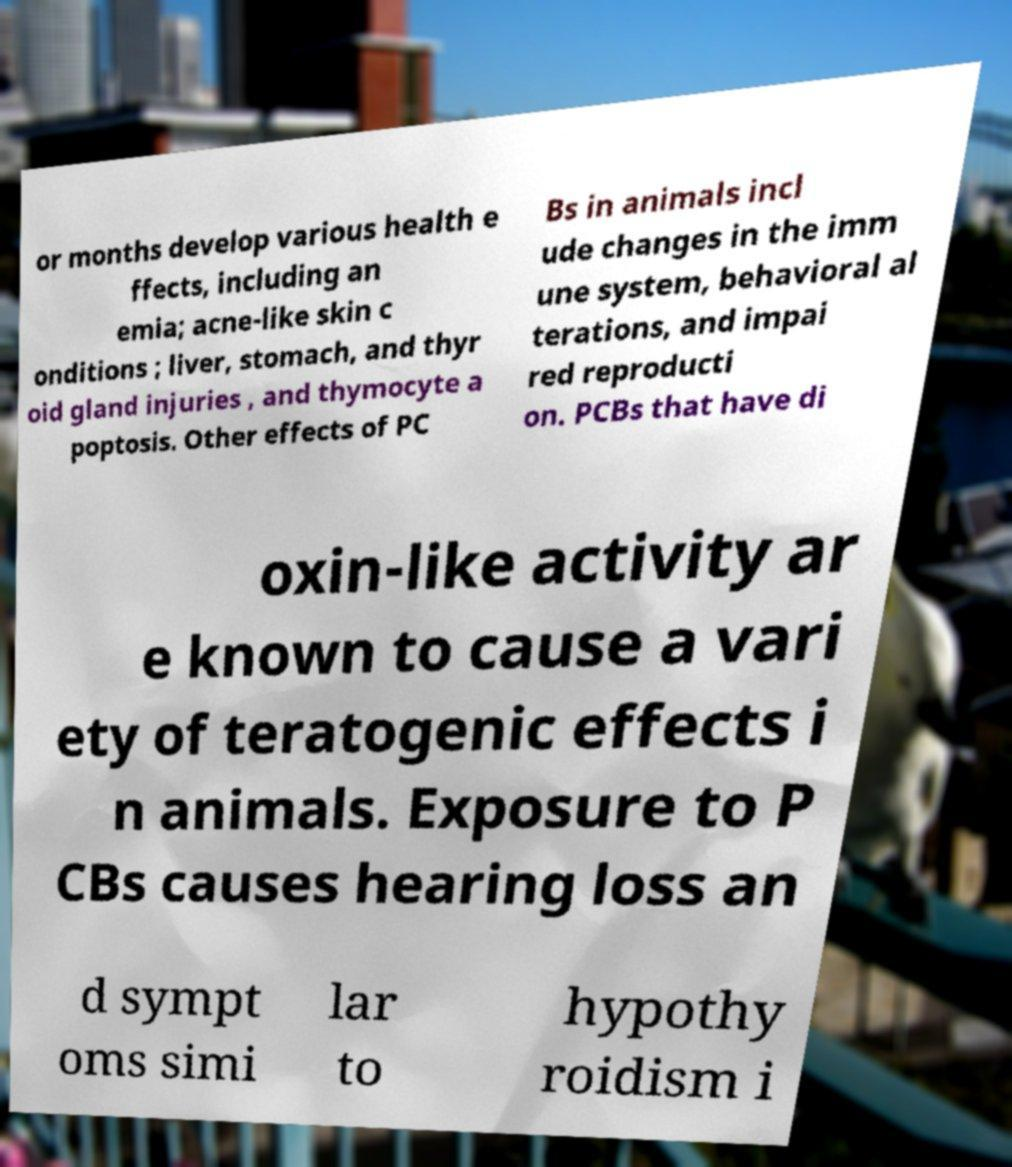What messages or text are displayed in this image? I need them in a readable, typed format. or months develop various health e ffects, including an emia; acne-like skin c onditions ; liver, stomach, and thyr oid gland injuries , and thymocyte a poptosis. Other effects of PC Bs in animals incl ude changes in the imm une system, behavioral al terations, and impai red reproducti on. PCBs that have di oxin-like activity ar e known to cause a vari ety of teratogenic effects i n animals. Exposure to P CBs causes hearing loss an d sympt oms simi lar to hypothy roidism i 